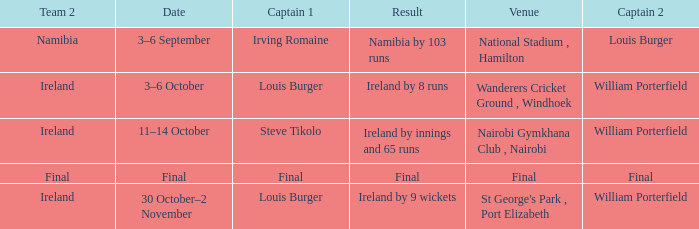Which Result has a Captain 1 of louis burger, and a Date of 30 october–2 november? Ireland by 9 wickets. 